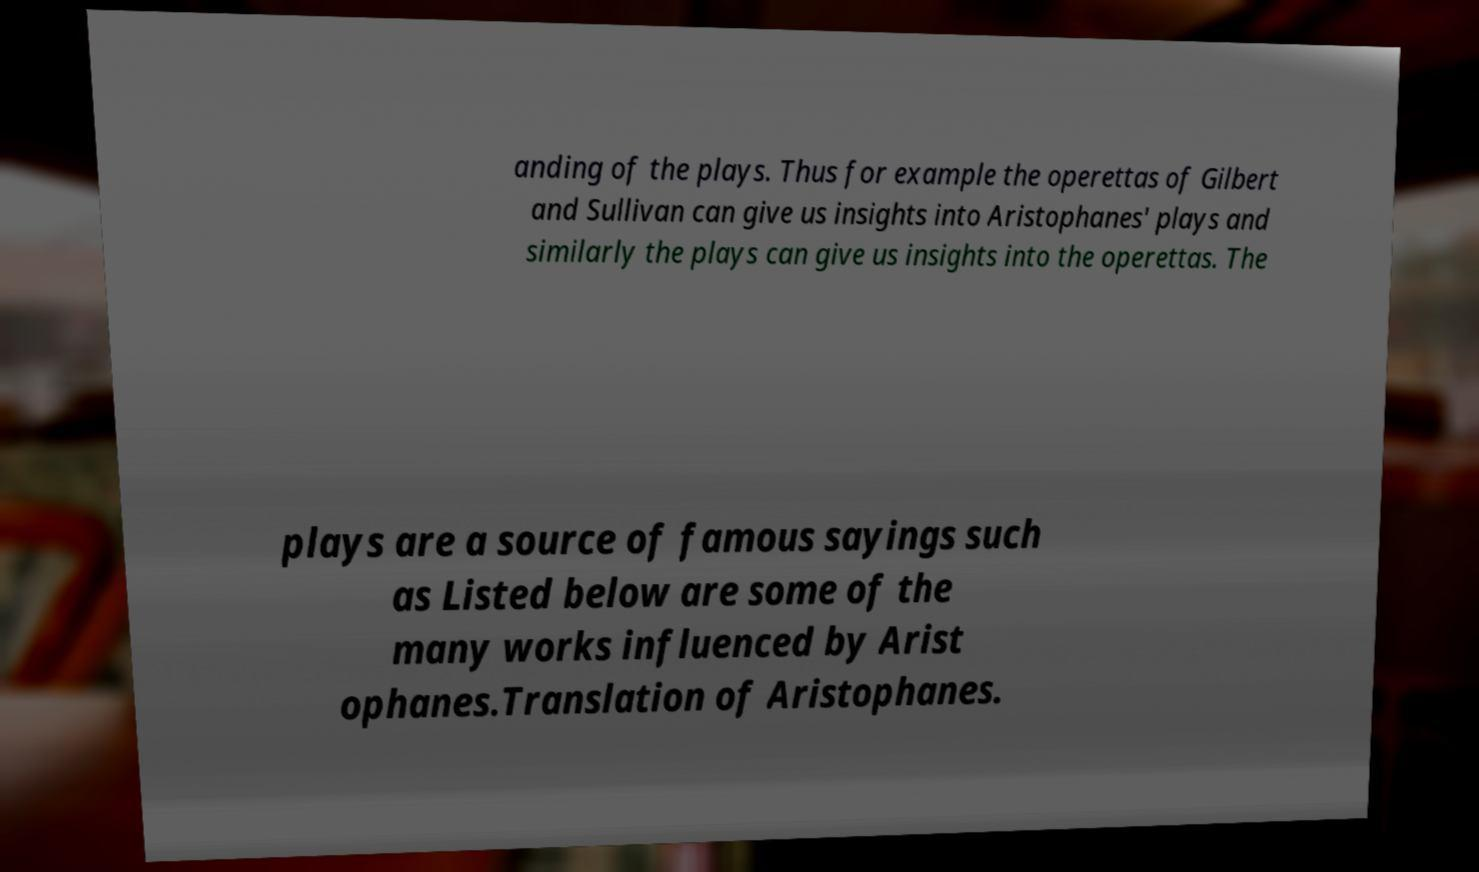Can you read and provide the text displayed in the image?This photo seems to have some interesting text. Can you extract and type it out for me? anding of the plays. Thus for example the operettas of Gilbert and Sullivan can give us insights into Aristophanes' plays and similarly the plays can give us insights into the operettas. The plays are a source of famous sayings such as Listed below are some of the many works influenced by Arist ophanes.Translation of Aristophanes. 